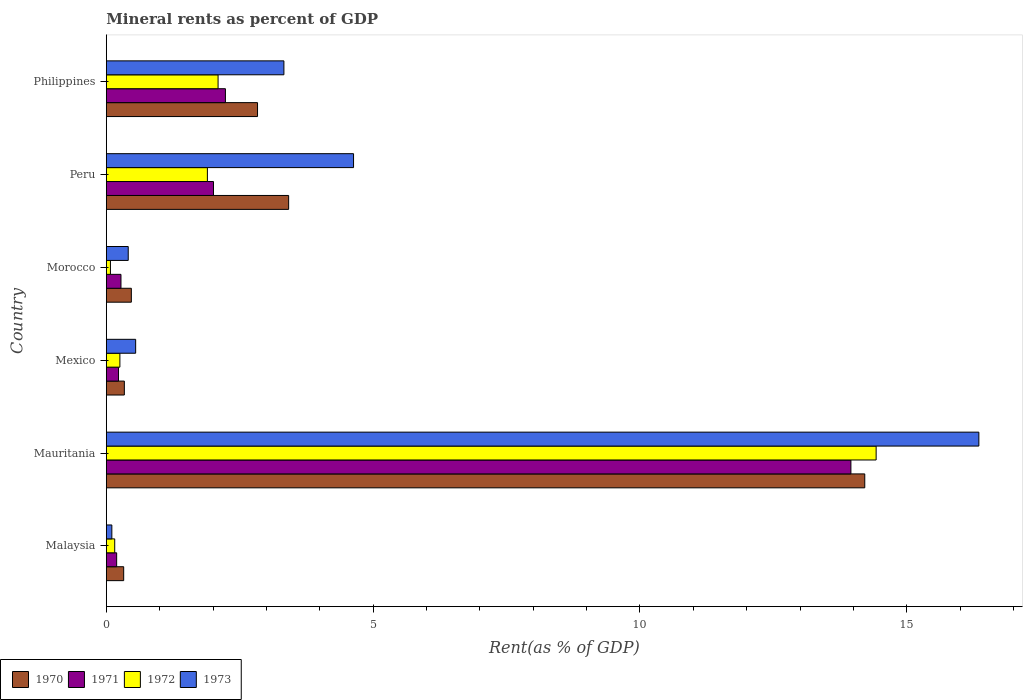How many different coloured bars are there?
Offer a terse response. 4. How many groups of bars are there?
Give a very brief answer. 6. Are the number of bars on each tick of the Y-axis equal?
Offer a terse response. Yes. How many bars are there on the 1st tick from the top?
Keep it short and to the point. 4. What is the label of the 1st group of bars from the top?
Your response must be concise. Philippines. What is the mineral rent in 1972 in Philippines?
Ensure brevity in your answer.  2.09. Across all countries, what is the maximum mineral rent in 1970?
Your answer should be very brief. 14.21. Across all countries, what is the minimum mineral rent in 1970?
Your answer should be very brief. 0.33. In which country was the mineral rent in 1971 maximum?
Make the answer very short. Mauritania. In which country was the mineral rent in 1970 minimum?
Provide a short and direct response. Malaysia. What is the total mineral rent in 1970 in the graph?
Offer a very short reply. 21.59. What is the difference between the mineral rent in 1972 in Malaysia and that in Morocco?
Your answer should be compact. 0.08. What is the difference between the mineral rent in 1970 in Morocco and the mineral rent in 1971 in Philippines?
Your answer should be very brief. -1.76. What is the average mineral rent in 1971 per country?
Provide a short and direct response. 3.15. What is the difference between the mineral rent in 1972 and mineral rent in 1971 in Philippines?
Your answer should be very brief. -0.14. What is the ratio of the mineral rent in 1973 in Mexico to that in Philippines?
Give a very brief answer. 0.17. What is the difference between the highest and the second highest mineral rent in 1970?
Offer a very short reply. 10.8. What is the difference between the highest and the lowest mineral rent in 1973?
Offer a terse response. 16.25. Is the sum of the mineral rent in 1970 in Mauritania and Peru greater than the maximum mineral rent in 1973 across all countries?
Keep it short and to the point. Yes. Is it the case that in every country, the sum of the mineral rent in 1971 and mineral rent in 1970 is greater than the sum of mineral rent in 1972 and mineral rent in 1973?
Make the answer very short. No. What does the 3rd bar from the bottom in Malaysia represents?
Your answer should be very brief. 1972. Is it the case that in every country, the sum of the mineral rent in 1970 and mineral rent in 1971 is greater than the mineral rent in 1973?
Give a very brief answer. Yes. Does the graph contain any zero values?
Offer a very short reply. No. Does the graph contain grids?
Provide a short and direct response. No. What is the title of the graph?
Your response must be concise. Mineral rents as percent of GDP. Does "1987" appear as one of the legend labels in the graph?
Provide a short and direct response. No. What is the label or title of the X-axis?
Provide a succinct answer. Rent(as % of GDP). What is the Rent(as % of GDP) of 1970 in Malaysia?
Make the answer very short. 0.33. What is the Rent(as % of GDP) in 1971 in Malaysia?
Give a very brief answer. 0.19. What is the Rent(as % of GDP) in 1972 in Malaysia?
Keep it short and to the point. 0.16. What is the Rent(as % of GDP) of 1973 in Malaysia?
Your response must be concise. 0.1. What is the Rent(as % of GDP) of 1970 in Mauritania?
Your response must be concise. 14.21. What is the Rent(as % of GDP) of 1971 in Mauritania?
Ensure brevity in your answer.  13.95. What is the Rent(as % of GDP) in 1972 in Mauritania?
Your response must be concise. 14.43. What is the Rent(as % of GDP) of 1973 in Mauritania?
Your response must be concise. 16.35. What is the Rent(as % of GDP) of 1970 in Mexico?
Offer a terse response. 0.34. What is the Rent(as % of GDP) of 1971 in Mexico?
Your answer should be compact. 0.23. What is the Rent(as % of GDP) in 1972 in Mexico?
Provide a succinct answer. 0.25. What is the Rent(as % of GDP) in 1973 in Mexico?
Give a very brief answer. 0.55. What is the Rent(as % of GDP) of 1970 in Morocco?
Ensure brevity in your answer.  0.47. What is the Rent(as % of GDP) in 1971 in Morocco?
Provide a succinct answer. 0.27. What is the Rent(as % of GDP) in 1972 in Morocco?
Keep it short and to the point. 0.08. What is the Rent(as % of GDP) in 1973 in Morocco?
Your answer should be very brief. 0.41. What is the Rent(as % of GDP) of 1970 in Peru?
Make the answer very short. 3.42. What is the Rent(as % of GDP) in 1971 in Peru?
Offer a terse response. 2.01. What is the Rent(as % of GDP) in 1972 in Peru?
Your answer should be very brief. 1.89. What is the Rent(as % of GDP) of 1973 in Peru?
Your response must be concise. 4.63. What is the Rent(as % of GDP) in 1970 in Philippines?
Offer a terse response. 2.83. What is the Rent(as % of GDP) in 1971 in Philippines?
Give a very brief answer. 2.23. What is the Rent(as % of GDP) in 1972 in Philippines?
Your response must be concise. 2.09. What is the Rent(as % of GDP) in 1973 in Philippines?
Offer a very short reply. 3.33. Across all countries, what is the maximum Rent(as % of GDP) in 1970?
Offer a very short reply. 14.21. Across all countries, what is the maximum Rent(as % of GDP) of 1971?
Your answer should be compact. 13.95. Across all countries, what is the maximum Rent(as % of GDP) in 1972?
Offer a very short reply. 14.43. Across all countries, what is the maximum Rent(as % of GDP) in 1973?
Make the answer very short. 16.35. Across all countries, what is the minimum Rent(as % of GDP) in 1970?
Offer a terse response. 0.33. Across all countries, what is the minimum Rent(as % of GDP) in 1971?
Provide a short and direct response. 0.19. Across all countries, what is the minimum Rent(as % of GDP) of 1972?
Your response must be concise. 0.08. Across all countries, what is the minimum Rent(as % of GDP) of 1973?
Your response must be concise. 0.1. What is the total Rent(as % of GDP) in 1970 in the graph?
Provide a succinct answer. 21.59. What is the total Rent(as % of GDP) of 1971 in the graph?
Your answer should be compact. 18.89. What is the total Rent(as % of GDP) in 1972 in the graph?
Offer a terse response. 18.9. What is the total Rent(as % of GDP) of 1973 in the graph?
Your answer should be very brief. 25.37. What is the difference between the Rent(as % of GDP) in 1970 in Malaysia and that in Mauritania?
Offer a terse response. -13.89. What is the difference between the Rent(as % of GDP) of 1971 in Malaysia and that in Mauritania?
Offer a terse response. -13.76. What is the difference between the Rent(as % of GDP) in 1972 in Malaysia and that in Mauritania?
Your answer should be compact. -14.27. What is the difference between the Rent(as % of GDP) in 1973 in Malaysia and that in Mauritania?
Provide a succinct answer. -16.25. What is the difference between the Rent(as % of GDP) of 1970 in Malaysia and that in Mexico?
Your answer should be compact. -0.01. What is the difference between the Rent(as % of GDP) in 1971 in Malaysia and that in Mexico?
Your response must be concise. -0.03. What is the difference between the Rent(as % of GDP) in 1972 in Malaysia and that in Mexico?
Make the answer very short. -0.1. What is the difference between the Rent(as % of GDP) of 1973 in Malaysia and that in Mexico?
Give a very brief answer. -0.45. What is the difference between the Rent(as % of GDP) in 1970 in Malaysia and that in Morocco?
Keep it short and to the point. -0.14. What is the difference between the Rent(as % of GDP) of 1971 in Malaysia and that in Morocco?
Provide a short and direct response. -0.08. What is the difference between the Rent(as % of GDP) of 1972 in Malaysia and that in Morocco?
Provide a succinct answer. 0.08. What is the difference between the Rent(as % of GDP) in 1973 in Malaysia and that in Morocco?
Your response must be concise. -0.31. What is the difference between the Rent(as % of GDP) of 1970 in Malaysia and that in Peru?
Offer a terse response. -3.09. What is the difference between the Rent(as % of GDP) of 1971 in Malaysia and that in Peru?
Your answer should be compact. -1.81. What is the difference between the Rent(as % of GDP) of 1972 in Malaysia and that in Peru?
Ensure brevity in your answer.  -1.74. What is the difference between the Rent(as % of GDP) of 1973 in Malaysia and that in Peru?
Keep it short and to the point. -4.53. What is the difference between the Rent(as % of GDP) in 1970 in Malaysia and that in Philippines?
Provide a succinct answer. -2.51. What is the difference between the Rent(as % of GDP) in 1971 in Malaysia and that in Philippines?
Your answer should be very brief. -2.04. What is the difference between the Rent(as % of GDP) in 1972 in Malaysia and that in Philippines?
Keep it short and to the point. -1.94. What is the difference between the Rent(as % of GDP) in 1973 in Malaysia and that in Philippines?
Make the answer very short. -3.22. What is the difference between the Rent(as % of GDP) of 1970 in Mauritania and that in Mexico?
Make the answer very short. 13.88. What is the difference between the Rent(as % of GDP) in 1971 in Mauritania and that in Mexico?
Ensure brevity in your answer.  13.72. What is the difference between the Rent(as % of GDP) of 1972 in Mauritania and that in Mexico?
Ensure brevity in your answer.  14.17. What is the difference between the Rent(as % of GDP) of 1973 in Mauritania and that in Mexico?
Provide a succinct answer. 15.8. What is the difference between the Rent(as % of GDP) in 1970 in Mauritania and that in Morocco?
Provide a short and direct response. 13.74. What is the difference between the Rent(as % of GDP) of 1971 in Mauritania and that in Morocco?
Ensure brevity in your answer.  13.68. What is the difference between the Rent(as % of GDP) of 1972 in Mauritania and that in Morocco?
Make the answer very short. 14.35. What is the difference between the Rent(as % of GDP) of 1973 in Mauritania and that in Morocco?
Provide a short and direct response. 15.94. What is the difference between the Rent(as % of GDP) in 1970 in Mauritania and that in Peru?
Provide a succinct answer. 10.8. What is the difference between the Rent(as % of GDP) in 1971 in Mauritania and that in Peru?
Ensure brevity in your answer.  11.94. What is the difference between the Rent(as % of GDP) of 1972 in Mauritania and that in Peru?
Offer a terse response. 12.53. What is the difference between the Rent(as % of GDP) of 1973 in Mauritania and that in Peru?
Keep it short and to the point. 11.72. What is the difference between the Rent(as % of GDP) in 1970 in Mauritania and that in Philippines?
Give a very brief answer. 11.38. What is the difference between the Rent(as % of GDP) of 1971 in Mauritania and that in Philippines?
Offer a very short reply. 11.72. What is the difference between the Rent(as % of GDP) in 1972 in Mauritania and that in Philippines?
Provide a short and direct response. 12.33. What is the difference between the Rent(as % of GDP) in 1973 in Mauritania and that in Philippines?
Offer a terse response. 13.02. What is the difference between the Rent(as % of GDP) of 1970 in Mexico and that in Morocco?
Provide a succinct answer. -0.13. What is the difference between the Rent(as % of GDP) in 1971 in Mexico and that in Morocco?
Keep it short and to the point. -0.05. What is the difference between the Rent(as % of GDP) in 1972 in Mexico and that in Morocco?
Give a very brief answer. 0.18. What is the difference between the Rent(as % of GDP) in 1973 in Mexico and that in Morocco?
Offer a very short reply. 0.14. What is the difference between the Rent(as % of GDP) in 1970 in Mexico and that in Peru?
Provide a short and direct response. -3.08. What is the difference between the Rent(as % of GDP) in 1971 in Mexico and that in Peru?
Make the answer very short. -1.78. What is the difference between the Rent(as % of GDP) of 1972 in Mexico and that in Peru?
Offer a terse response. -1.64. What is the difference between the Rent(as % of GDP) in 1973 in Mexico and that in Peru?
Keep it short and to the point. -4.08. What is the difference between the Rent(as % of GDP) of 1970 in Mexico and that in Philippines?
Make the answer very short. -2.5. What is the difference between the Rent(as % of GDP) of 1971 in Mexico and that in Philippines?
Keep it short and to the point. -2. What is the difference between the Rent(as % of GDP) of 1972 in Mexico and that in Philippines?
Give a very brief answer. -1.84. What is the difference between the Rent(as % of GDP) in 1973 in Mexico and that in Philippines?
Offer a terse response. -2.78. What is the difference between the Rent(as % of GDP) in 1970 in Morocco and that in Peru?
Your response must be concise. -2.95. What is the difference between the Rent(as % of GDP) in 1971 in Morocco and that in Peru?
Give a very brief answer. -1.73. What is the difference between the Rent(as % of GDP) of 1972 in Morocco and that in Peru?
Provide a short and direct response. -1.82. What is the difference between the Rent(as % of GDP) of 1973 in Morocco and that in Peru?
Your response must be concise. -4.22. What is the difference between the Rent(as % of GDP) in 1970 in Morocco and that in Philippines?
Give a very brief answer. -2.36. What is the difference between the Rent(as % of GDP) in 1971 in Morocco and that in Philippines?
Your answer should be compact. -1.96. What is the difference between the Rent(as % of GDP) in 1972 in Morocco and that in Philippines?
Provide a short and direct response. -2.02. What is the difference between the Rent(as % of GDP) in 1973 in Morocco and that in Philippines?
Give a very brief answer. -2.92. What is the difference between the Rent(as % of GDP) of 1970 in Peru and that in Philippines?
Ensure brevity in your answer.  0.58. What is the difference between the Rent(as % of GDP) of 1971 in Peru and that in Philippines?
Make the answer very short. -0.22. What is the difference between the Rent(as % of GDP) of 1972 in Peru and that in Philippines?
Give a very brief answer. -0.2. What is the difference between the Rent(as % of GDP) of 1973 in Peru and that in Philippines?
Ensure brevity in your answer.  1.31. What is the difference between the Rent(as % of GDP) of 1970 in Malaysia and the Rent(as % of GDP) of 1971 in Mauritania?
Provide a short and direct response. -13.63. What is the difference between the Rent(as % of GDP) in 1970 in Malaysia and the Rent(as % of GDP) in 1972 in Mauritania?
Make the answer very short. -14.1. What is the difference between the Rent(as % of GDP) of 1970 in Malaysia and the Rent(as % of GDP) of 1973 in Mauritania?
Your answer should be very brief. -16.03. What is the difference between the Rent(as % of GDP) of 1971 in Malaysia and the Rent(as % of GDP) of 1972 in Mauritania?
Ensure brevity in your answer.  -14.23. What is the difference between the Rent(as % of GDP) in 1971 in Malaysia and the Rent(as % of GDP) in 1973 in Mauritania?
Your answer should be very brief. -16.16. What is the difference between the Rent(as % of GDP) of 1972 in Malaysia and the Rent(as % of GDP) of 1973 in Mauritania?
Ensure brevity in your answer.  -16.19. What is the difference between the Rent(as % of GDP) in 1970 in Malaysia and the Rent(as % of GDP) in 1971 in Mexico?
Make the answer very short. 0.1. What is the difference between the Rent(as % of GDP) of 1970 in Malaysia and the Rent(as % of GDP) of 1972 in Mexico?
Offer a terse response. 0.07. What is the difference between the Rent(as % of GDP) of 1970 in Malaysia and the Rent(as % of GDP) of 1973 in Mexico?
Give a very brief answer. -0.22. What is the difference between the Rent(as % of GDP) in 1971 in Malaysia and the Rent(as % of GDP) in 1972 in Mexico?
Offer a terse response. -0.06. What is the difference between the Rent(as % of GDP) in 1971 in Malaysia and the Rent(as % of GDP) in 1973 in Mexico?
Your answer should be compact. -0.36. What is the difference between the Rent(as % of GDP) of 1972 in Malaysia and the Rent(as % of GDP) of 1973 in Mexico?
Provide a short and direct response. -0.39. What is the difference between the Rent(as % of GDP) of 1970 in Malaysia and the Rent(as % of GDP) of 1971 in Morocco?
Provide a succinct answer. 0.05. What is the difference between the Rent(as % of GDP) of 1970 in Malaysia and the Rent(as % of GDP) of 1972 in Morocco?
Ensure brevity in your answer.  0.25. What is the difference between the Rent(as % of GDP) of 1970 in Malaysia and the Rent(as % of GDP) of 1973 in Morocco?
Offer a terse response. -0.09. What is the difference between the Rent(as % of GDP) in 1971 in Malaysia and the Rent(as % of GDP) in 1972 in Morocco?
Make the answer very short. 0.12. What is the difference between the Rent(as % of GDP) in 1971 in Malaysia and the Rent(as % of GDP) in 1973 in Morocco?
Give a very brief answer. -0.22. What is the difference between the Rent(as % of GDP) of 1972 in Malaysia and the Rent(as % of GDP) of 1973 in Morocco?
Offer a terse response. -0.25. What is the difference between the Rent(as % of GDP) in 1970 in Malaysia and the Rent(as % of GDP) in 1971 in Peru?
Your answer should be very brief. -1.68. What is the difference between the Rent(as % of GDP) of 1970 in Malaysia and the Rent(as % of GDP) of 1972 in Peru?
Provide a short and direct response. -1.57. What is the difference between the Rent(as % of GDP) of 1970 in Malaysia and the Rent(as % of GDP) of 1973 in Peru?
Provide a short and direct response. -4.31. What is the difference between the Rent(as % of GDP) in 1971 in Malaysia and the Rent(as % of GDP) in 1972 in Peru?
Give a very brief answer. -1.7. What is the difference between the Rent(as % of GDP) in 1971 in Malaysia and the Rent(as % of GDP) in 1973 in Peru?
Your answer should be compact. -4.44. What is the difference between the Rent(as % of GDP) of 1972 in Malaysia and the Rent(as % of GDP) of 1973 in Peru?
Your answer should be compact. -4.48. What is the difference between the Rent(as % of GDP) in 1970 in Malaysia and the Rent(as % of GDP) in 1971 in Philippines?
Offer a very short reply. -1.91. What is the difference between the Rent(as % of GDP) of 1970 in Malaysia and the Rent(as % of GDP) of 1972 in Philippines?
Your answer should be very brief. -1.77. What is the difference between the Rent(as % of GDP) in 1970 in Malaysia and the Rent(as % of GDP) in 1973 in Philippines?
Ensure brevity in your answer.  -3. What is the difference between the Rent(as % of GDP) in 1971 in Malaysia and the Rent(as % of GDP) in 1972 in Philippines?
Provide a short and direct response. -1.9. What is the difference between the Rent(as % of GDP) of 1971 in Malaysia and the Rent(as % of GDP) of 1973 in Philippines?
Provide a short and direct response. -3.13. What is the difference between the Rent(as % of GDP) in 1972 in Malaysia and the Rent(as % of GDP) in 1973 in Philippines?
Your answer should be very brief. -3.17. What is the difference between the Rent(as % of GDP) in 1970 in Mauritania and the Rent(as % of GDP) in 1971 in Mexico?
Provide a short and direct response. 13.98. What is the difference between the Rent(as % of GDP) in 1970 in Mauritania and the Rent(as % of GDP) in 1972 in Mexico?
Provide a short and direct response. 13.96. What is the difference between the Rent(as % of GDP) of 1970 in Mauritania and the Rent(as % of GDP) of 1973 in Mexico?
Provide a succinct answer. 13.66. What is the difference between the Rent(as % of GDP) in 1971 in Mauritania and the Rent(as % of GDP) in 1972 in Mexico?
Your response must be concise. 13.7. What is the difference between the Rent(as % of GDP) of 1971 in Mauritania and the Rent(as % of GDP) of 1973 in Mexico?
Provide a short and direct response. 13.4. What is the difference between the Rent(as % of GDP) of 1972 in Mauritania and the Rent(as % of GDP) of 1973 in Mexico?
Offer a very short reply. 13.88. What is the difference between the Rent(as % of GDP) of 1970 in Mauritania and the Rent(as % of GDP) of 1971 in Morocco?
Give a very brief answer. 13.94. What is the difference between the Rent(as % of GDP) of 1970 in Mauritania and the Rent(as % of GDP) of 1972 in Morocco?
Provide a short and direct response. 14.14. What is the difference between the Rent(as % of GDP) in 1970 in Mauritania and the Rent(as % of GDP) in 1973 in Morocco?
Your answer should be very brief. 13.8. What is the difference between the Rent(as % of GDP) of 1971 in Mauritania and the Rent(as % of GDP) of 1972 in Morocco?
Ensure brevity in your answer.  13.88. What is the difference between the Rent(as % of GDP) of 1971 in Mauritania and the Rent(as % of GDP) of 1973 in Morocco?
Your answer should be compact. 13.54. What is the difference between the Rent(as % of GDP) of 1972 in Mauritania and the Rent(as % of GDP) of 1973 in Morocco?
Provide a short and direct response. 14.02. What is the difference between the Rent(as % of GDP) of 1970 in Mauritania and the Rent(as % of GDP) of 1971 in Peru?
Keep it short and to the point. 12.2. What is the difference between the Rent(as % of GDP) of 1970 in Mauritania and the Rent(as % of GDP) of 1972 in Peru?
Your answer should be compact. 12.32. What is the difference between the Rent(as % of GDP) in 1970 in Mauritania and the Rent(as % of GDP) in 1973 in Peru?
Provide a succinct answer. 9.58. What is the difference between the Rent(as % of GDP) in 1971 in Mauritania and the Rent(as % of GDP) in 1972 in Peru?
Make the answer very short. 12.06. What is the difference between the Rent(as % of GDP) of 1971 in Mauritania and the Rent(as % of GDP) of 1973 in Peru?
Give a very brief answer. 9.32. What is the difference between the Rent(as % of GDP) in 1972 in Mauritania and the Rent(as % of GDP) in 1973 in Peru?
Make the answer very short. 9.79. What is the difference between the Rent(as % of GDP) of 1970 in Mauritania and the Rent(as % of GDP) of 1971 in Philippines?
Make the answer very short. 11.98. What is the difference between the Rent(as % of GDP) in 1970 in Mauritania and the Rent(as % of GDP) in 1972 in Philippines?
Keep it short and to the point. 12.12. What is the difference between the Rent(as % of GDP) of 1970 in Mauritania and the Rent(as % of GDP) of 1973 in Philippines?
Make the answer very short. 10.89. What is the difference between the Rent(as % of GDP) of 1971 in Mauritania and the Rent(as % of GDP) of 1972 in Philippines?
Make the answer very short. 11.86. What is the difference between the Rent(as % of GDP) in 1971 in Mauritania and the Rent(as % of GDP) in 1973 in Philippines?
Make the answer very short. 10.63. What is the difference between the Rent(as % of GDP) in 1972 in Mauritania and the Rent(as % of GDP) in 1973 in Philippines?
Offer a very short reply. 11.1. What is the difference between the Rent(as % of GDP) of 1970 in Mexico and the Rent(as % of GDP) of 1971 in Morocco?
Your answer should be compact. 0.06. What is the difference between the Rent(as % of GDP) in 1970 in Mexico and the Rent(as % of GDP) in 1972 in Morocco?
Offer a terse response. 0.26. What is the difference between the Rent(as % of GDP) in 1970 in Mexico and the Rent(as % of GDP) in 1973 in Morocco?
Ensure brevity in your answer.  -0.07. What is the difference between the Rent(as % of GDP) of 1971 in Mexico and the Rent(as % of GDP) of 1972 in Morocco?
Your response must be concise. 0.15. What is the difference between the Rent(as % of GDP) of 1971 in Mexico and the Rent(as % of GDP) of 1973 in Morocco?
Ensure brevity in your answer.  -0.18. What is the difference between the Rent(as % of GDP) of 1972 in Mexico and the Rent(as % of GDP) of 1973 in Morocco?
Provide a short and direct response. -0.16. What is the difference between the Rent(as % of GDP) in 1970 in Mexico and the Rent(as % of GDP) in 1971 in Peru?
Offer a terse response. -1.67. What is the difference between the Rent(as % of GDP) in 1970 in Mexico and the Rent(as % of GDP) in 1972 in Peru?
Offer a very short reply. -1.56. What is the difference between the Rent(as % of GDP) in 1970 in Mexico and the Rent(as % of GDP) in 1973 in Peru?
Your response must be concise. -4.29. What is the difference between the Rent(as % of GDP) in 1971 in Mexico and the Rent(as % of GDP) in 1972 in Peru?
Give a very brief answer. -1.67. What is the difference between the Rent(as % of GDP) of 1971 in Mexico and the Rent(as % of GDP) of 1973 in Peru?
Offer a terse response. -4.4. What is the difference between the Rent(as % of GDP) in 1972 in Mexico and the Rent(as % of GDP) in 1973 in Peru?
Provide a short and direct response. -4.38. What is the difference between the Rent(as % of GDP) in 1970 in Mexico and the Rent(as % of GDP) in 1971 in Philippines?
Make the answer very short. -1.89. What is the difference between the Rent(as % of GDP) in 1970 in Mexico and the Rent(as % of GDP) in 1972 in Philippines?
Provide a succinct answer. -1.76. What is the difference between the Rent(as % of GDP) in 1970 in Mexico and the Rent(as % of GDP) in 1973 in Philippines?
Provide a short and direct response. -2.99. What is the difference between the Rent(as % of GDP) in 1971 in Mexico and the Rent(as % of GDP) in 1972 in Philippines?
Offer a terse response. -1.87. What is the difference between the Rent(as % of GDP) in 1971 in Mexico and the Rent(as % of GDP) in 1973 in Philippines?
Your response must be concise. -3.1. What is the difference between the Rent(as % of GDP) of 1972 in Mexico and the Rent(as % of GDP) of 1973 in Philippines?
Your response must be concise. -3.07. What is the difference between the Rent(as % of GDP) of 1970 in Morocco and the Rent(as % of GDP) of 1971 in Peru?
Make the answer very short. -1.54. What is the difference between the Rent(as % of GDP) of 1970 in Morocco and the Rent(as % of GDP) of 1972 in Peru?
Your answer should be very brief. -1.43. What is the difference between the Rent(as % of GDP) of 1970 in Morocco and the Rent(as % of GDP) of 1973 in Peru?
Offer a terse response. -4.16. What is the difference between the Rent(as % of GDP) in 1971 in Morocco and the Rent(as % of GDP) in 1972 in Peru?
Provide a short and direct response. -1.62. What is the difference between the Rent(as % of GDP) of 1971 in Morocco and the Rent(as % of GDP) of 1973 in Peru?
Provide a succinct answer. -4.36. What is the difference between the Rent(as % of GDP) of 1972 in Morocco and the Rent(as % of GDP) of 1973 in Peru?
Give a very brief answer. -4.56. What is the difference between the Rent(as % of GDP) in 1970 in Morocco and the Rent(as % of GDP) in 1971 in Philippines?
Ensure brevity in your answer.  -1.76. What is the difference between the Rent(as % of GDP) in 1970 in Morocco and the Rent(as % of GDP) in 1972 in Philippines?
Offer a terse response. -1.63. What is the difference between the Rent(as % of GDP) in 1970 in Morocco and the Rent(as % of GDP) in 1973 in Philippines?
Give a very brief answer. -2.86. What is the difference between the Rent(as % of GDP) in 1971 in Morocco and the Rent(as % of GDP) in 1972 in Philippines?
Your answer should be compact. -1.82. What is the difference between the Rent(as % of GDP) in 1971 in Morocco and the Rent(as % of GDP) in 1973 in Philippines?
Offer a very short reply. -3.05. What is the difference between the Rent(as % of GDP) of 1972 in Morocco and the Rent(as % of GDP) of 1973 in Philippines?
Offer a terse response. -3.25. What is the difference between the Rent(as % of GDP) of 1970 in Peru and the Rent(as % of GDP) of 1971 in Philippines?
Ensure brevity in your answer.  1.18. What is the difference between the Rent(as % of GDP) in 1970 in Peru and the Rent(as % of GDP) in 1972 in Philippines?
Make the answer very short. 1.32. What is the difference between the Rent(as % of GDP) of 1970 in Peru and the Rent(as % of GDP) of 1973 in Philippines?
Give a very brief answer. 0.09. What is the difference between the Rent(as % of GDP) of 1971 in Peru and the Rent(as % of GDP) of 1972 in Philippines?
Your answer should be compact. -0.09. What is the difference between the Rent(as % of GDP) in 1971 in Peru and the Rent(as % of GDP) in 1973 in Philippines?
Offer a very short reply. -1.32. What is the difference between the Rent(as % of GDP) of 1972 in Peru and the Rent(as % of GDP) of 1973 in Philippines?
Your answer should be very brief. -1.43. What is the average Rent(as % of GDP) of 1970 per country?
Keep it short and to the point. 3.6. What is the average Rent(as % of GDP) in 1971 per country?
Your response must be concise. 3.15. What is the average Rent(as % of GDP) in 1972 per country?
Your answer should be very brief. 3.15. What is the average Rent(as % of GDP) of 1973 per country?
Ensure brevity in your answer.  4.23. What is the difference between the Rent(as % of GDP) in 1970 and Rent(as % of GDP) in 1971 in Malaysia?
Provide a short and direct response. 0.13. What is the difference between the Rent(as % of GDP) of 1970 and Rent(as % of GDP) of 1972 in Malaysia?
Offer a terse response. 0.17. What is the difference between the Rent(as % of GDP) of 1970 and Rent(as % of GDP) of 1973 in Malaysia?
Keep it short and to the point. 0.22. What is the difference between the Rent(as % of GDP) in 1971 and Rent(as % of GDP) in 1972 in Malaysia?
Offer a very short reply. 0.04. What is the difference between the Rent(as % of GDP) of 1971 and Rent(as % of GDP) of 1973 in Malaysia?
Provide a succinct answer. 0.09. What is the difference between the Rent(as % of GDP) in 1972 and Rent(as % of GDP) in 1973 in Malaysia?
Your answer should be compact. 0.05. What is the difference between the Rent(as % of GDP) in 1970 and Rent(as % of GDP) in 1971 in Mauritania?
Give a very brief answer. 0.26. What is the difference between the Rent(as % of GDP) of 1970 and Rent(as % of GDP) of 1972 in Mauritania?
Give a very brief answer. -0.21. What is the difference between the Rent(as % of GDP) of 1970 and Rent(as % of GDP) of 1973 in Mauritania?
Keep it short and to the point. -2.14. What is the difference between the Rent(as % of GDP) of 1971 and Rent(as % of GDP) of 1972 in Mauritania?
Your response must be concise. -0.47. What is the difference between the Rent(as % of GDP) in 1971 and Rent(as % of GDP) in 1973 in Mauritania?
Offer a terse response. -2.4. What is the difference between the Rent(as % of GDP) of 1972 and Rent(as % of GDP) of 1973 in Mauritania?
Your response must be concise. -1.93. What is the difference between the Rent(as % of GDP) of 1970 and Rent(as % of GDP) of 1971 in Mexico?
Your answer should be very brief. 0.11. What is the difference between the Rent(as % of GDP) of 1970 and Rent(as % of GDP) of 1972 in Mexico?
Offer a very short reply. 0.08. What is the difference between the Rent(as % of GDP) of 1970 and Rent(as % of GDP) of 1973 in Mexico?
Your response must be concise. -0.21. What is the difference between the Rent(as % of GDP) in 1971 and Rent(as % of GDP) in 1972 in Mexico?
Offer a terse response. -0.03. What is the difference between the Rent(as % of GDP) of 1971 and Rent(as % of GDP) of 1973 in Mexico?
Your answer should be very brief. -0.32. What is the difference between the Rent(as % of GDP) in 1972 and Rent(as % of GDP) in 1973 in Mexico?
Offer a very short reply. -0.3. What is the difference between the Rent(as % of GDP) in 1970 and Rent(as % of GDP) in 1971 in Morocco?
Your answer should be very brief. 0.19. What is the difference between the Rent(as % of GDP) in 1970 and Rent(as % of GDP) in 1972 in Morocco?
Keep it short and to the point. 0.39. What is the difference between the Rent(as % of GDP) in 1970 and Rent(as % of GDP) in 1973 in Morocco?
Provide a short and direct response. 0.06. What is the difference between the Rent(as % of GDP) in 1971 and Rent(as % of GDP) in 1972 in Morocco?
Keep it short and to the point. 0.2. What is the difference between the Rent(as % of GDP) in 1971 and Rent(as % of GDP) in 1973 in Morocco?
Your response must be concise. -0.14. What is the difference between the Rent(as % of GDP) of 1972 and Rent(as % of GDP) of 1973 in Morocco?
Ensure brevity in your answer.  -0.33. What is the difference between the Rent(as % of GDP) of 1970 and Rent(as % of GDP) of 1971 in Peru?
Offer a very short reply. 1.41. What is the difference between the Rent(as % of GDP) of 1970 and Rent(as % of GDP) of 1972 in Peru?
Your answer should be compact. 1.52. What is the difference between the Rent(as % of GDP) of 1970 and Rent(as % of GDP) of 1973 in Peru?
Provide a succinct answer. -1.22. What is the difference between the Rent(as % of GDP) in 1971 and Rent(as % of GDP) in 1972 in Peru?
Make the answer very short. 0.11. What is the difference between the Rent(as % of GDP) of 1971 and Rent(as % of GDP) of 1973 in Peru?
Keep it short and to the point. -2.62. What is the difference between the Rent(as % of GDP) in 1972 and Rent(as % of GDP) in 1973 in Peru?
Offer a very short reply. -2.74. What is the difference between the Rent(as % of GDP) of 1970 and Rent(as % of GDP) of 1971 in Philippines?
Offer a terse response. 0.6. What is the difference between the Rent(as % of GDP) of 1970 and Rent(as % of GDP) of 1972 in Philippines?
Your response must be concise. 0.74. What is the difference between the Rent(as % of GDP) of 1970 and Rent(as % of GDP) of 1973 in Philippines?
Give a very brief answer. -0.49. What is the difference between the Rent(as % of GDP) of 1971 and Rent(as % of GDP) of 1972 in Philippines?
Give a very brief answer. 0.14. What is the difference between the Rent(as % of GDP) of 1971 and Rent(as % of GDP) of 1973 in Philippines?
Your answer should be compact. -1.1. What is the difference between the Rent(as % of GDP) in 1972 and Rent(as % of GDP) in 1973 in Philippines?
Offer a very short reply. -1.23. What is the ratio of the Rent(as % of GDP) of 1970 in Malaysia to that in Mauritania?
Offer a very short reply. 0.02. What is the ratio of the Rent(as % of GDP) in 1971 in Malaysia to that in Mauritania?
Provide a short and direct response. 0.01. What is the ratio of the Rent(as % of GDP) in 1972 in Malaysia to that in Mauritania?
Make the answer very short. 0.01. What is the ratio of the Rent(as % of GDP) in 1973 in Malaysia to that in Mauritania?
Offer a very short reply. 0.01. What is the ratio of the Rent(as % of GDP) in 1970 in Malaysia to that in Mexico?
Offer a terse response. 0.96. What is the ratio of the Rent(as % of GDP) in 1971 in Malaysia to that in Mexico?
Give a very brief answer. 0.85. What is the ratio of the Rent(as % of GDP) in 1972 in Malaysia to that in Mexico?
Keep it short and to the point. 0.62. What is the ratio of the Rent(as % of GDP) in 1973 in Malaysia to that in Mexico?
Make the answer very short. 0.19. What is the ratio of the Rent(as % of GDP) in 1970 in Malaysia to that in Morocco?
Offer a very short reply. 0.69. What is the ratio of the Rent(as % of GDP) of 1971 in Malaysia to that in Morocco?
Give a very brief answer. 0.71. What is the ratio of the Rent(as % of GDP) of 1972 in Malaysia to that in Morocco?
Make the answer very short. 2.04. What is the ratio of the Rent(as % of GDP) in 1973 in Malaysia to that in Morocco?
Your answer should be very brief. 0.25. What is the ratio of the Rent(as % of GDP) of 1970 in Malaysia to that in Peru?
Your response must be concise. 0.1. What is the ratio of the Rent(as % of GDP) of 1971 in Malaysia to that in Peru?
Offer a terse response. 0.1. What is the ratio of the Rent(as % of GDP) in 1972 in Malaysia to that in Peru?
Ensure brevity in your answer.  0.08. What is the ratio of the Rent(as % of GDP) of 1973 in Malaysia to that in Peru?
Your response must be concise. 0.02. What is the ratio of the Rent(as % of GDP) in 1970 in Malaysia to that in Philippines?
Offer a very short reply. 0.11. What is the ratio of the Rent(as % of GDP) of 1971 in Malaysia to that in Philippines?
Make the answer very short. 0.09. What is the ratio of the Rent(as % of GDP) in 1972 in Malaysia to that in Philippines?
Provide a short and direct response. 0.07. What is the ratio of the Rent(as % of GDP) of 1973 in Malaysia to that in Philippines?
Ensure brevity in your answer.  0.03. What is the ratio of the Rent(as % of GDP) in 1970 in Mauritania to that in Mexico?
Give a very brief answer. 42.1. What is the ratio of the Rent(as % of GDP) in 1971 in Mauritania to that in Mexico?
Provide a succinct answer. 61.1. What is the ratio of the Rent(as % of GDP) in 1972 in Mauritania to that in Mexico?
Give a very brief answer. 56.78. What is the ratio of the Rent(as % of GDP) of 1973 in Mauritania to that in Mexico?
Your answer should be very brief. 29.75. What is the ratio of the Rent(as % of GDP) of 1970 in Mauritania to that in Morocco?
Your response must be concise. 30.32. What is the ratio of the Rent(as % of GDP) in 1971 in Mauritania to that in Morocco?
Provide a short and direct response. 50.9. What is the ratio of the Rent(as % of GDP) of 1972 in Mauritania to that in Morocco?
Provide a short and direct response. 187.82. What is the ratio of the Rent(as % of GDP) in 1973 in Mauritania to that in Morocco?
Provide a succinct answer. 39.85. What is the ratio of the Rent(as % of GDP) in 1970 in Mauritania to that in Peru?
Your answer should be very brief. 4.16. What is the ratio of the Rent(as % of GDP) in 1971 in Mauritania to that in Peru?
Provide a succinct answer. 6.95. What is the ratio of the Rent(as % of GDP) of 1972 in Mauritania to that in Peru?
Provide a short and direct response. 7.62. What is the ratio of the Rent(as % of GDP) of 1973 in Mauritania to that in Peru?
Offer a very short reply. 3.53. What is the ratio of the Rent(as % of GDP) in 1970 in Mauritania to that in Philippines?
Offer a very short reply. 5.02. What is the ratio of the Rent(as % of GDP) of 1971 in Mauritania to that in Philippines?
Provide a succinct answer. 6.25. What is the ratio of the Rent(as % of GDP) of 1972 in Mauritania to that in Philippines?
Provide a short and direct response. 6.89. What is the ratio of the Rent(as % of GDP) in 1973 in Mauritania to that in Philippines?
Provide a succinct answer. 4.91. What is the ratio of the Rent(as % of GDP) of 1970 in Mexico to that in Morocco?
Your answer should be compact. 0.72. What is the ratio of the Rent(as % of GDP) in 1971 in Mexico to that in Morocco?
Give a very brief answer. 0.83. What is the ratio of the Rent(as % of GDP) of 1972 in Mexico to that in Morocco?
Keep it short and to the point. 3.31. What is the ratio of the Rent(as % of GDP) of 1973 in Mexico to that in Morocco?
Make the answer very short. 1.34. What is the ratio of the Rent(as % of GDP) of 1970 in Mexico to that in Peru?
Your answer should be very brief. 0.1. What is the ratio of the Rent(as % of GDP) in 1971 in Mexico to that in Peru?
Your answer should be compact. 0.11. What is the ratio of the Rent(as % of GDP) in 1972 in Mexico to that in Peru?
Your answer should be compact. 0.13. What is the ratio of the Rent(as % of GDP) in 1973 in Mexico to that in Peru?
Provide a succinct answer. 0.12. What is the ratio of the Rent(as % of GDP) in 1970 in Mexico to that in Philippines?
Keep it short and to the point. 0.12. What is the ratio of the Rent(as % of GDP) in 1971 in Mexico to that in Philippines?
Make the answer very short. 0.1. What is the ratio of the Rent(as % of GDP) of 1972 in Mexico to that in Philippines?
Your answer should be very brief. 0.12. What is the ratio of the Rent(as % of GDP) of 1973 in Mexico to that in Philippines?
Offer a terse response. 0.17. What is the ratio of the Rent(as % of GDP) in 1970 in Morocco to that in Peru?
Ensure brevity in your answer.  0.14. What is the ratio of the Rent(as % of GDP) of 1971 in Morocco to that in Peru?
Offer a terse response. 0.14. What is the ratio of the Rent(as % of GDP) in 1972 in Morocco to that in Peru?
Make the answer very short. 0.04. What is the ratio of the Rent(as % of GDP) in 1973 in Morocco to that in Peru?
Ensure brevity in your answer.  0.09. What is the ratio of the Rent(as % of GDP) in 1970 in Morocco to that in Philippines?
Offer a terse response. 0.17. What is the ratio of the Rent(as % of GDP) in 1971 in Morocco to that in Philippines?
Provide a succinct answer. 0.12. What is the ratio of the Rent(as % of GDP) of 1972 in Morocco to that in Philippines?
Your answer should be compact. 0.04. What is the ratio of the Rent(as % of GDP) of 1973 in Morocco to that in Philippines?
Ensure brevity in your answer.  0.12. What is the ratio of the Rent(as % of GDP) in 1970 in Peru to that in Philippines?
Your answer should be very brief. 1.21. What is the ratio of the Rent(as % of GDP) in 1971 in Peru to that in Philippines?
Make the answer very short. 0.9. What is the ratio of the Rent(as % of GDP) of 1972 in Peru to that in Philippines?
Keep it short and to the point. 0.9. What is the ratio of the Rent(as % of GDP) in 1973 in Peru to that in Philippines?
Your answer should be compact. 1.39. What is the difference between the highest and the second highest Rent(as % of GDP) of 1970?
Ensure brevity in your answer.  10.8. What is the difference between the highest and the second highest Rent(as % of GDP) of 1971?
Offer a terse response. 11.72. What is the difference between the highest and the second highest Rent(as % of GDP) of 1972?
Your response must be concise. 12.33. What is the difference between the highest and the second highest Rent(as % of GDP) in 1973?
Ensure brevity in your answer.  11.72. What is the difference between the highest and the lowest Rent(as % of GDP) in 1970?
Your response must be concise. 13.89. What is the difference between the highest and the lowest Rent(as % of GDP) of 1971?
Your answer should be very brief. 13.76. What is the difference between the highest and the lowest Rent(as % of GDP) in 1972?
Provide a succinct answer. 14.35. What is the difference between the highest and the lowest Rent(as % of GDP) in 1973?
Provide a succinct answer. 16.25. 